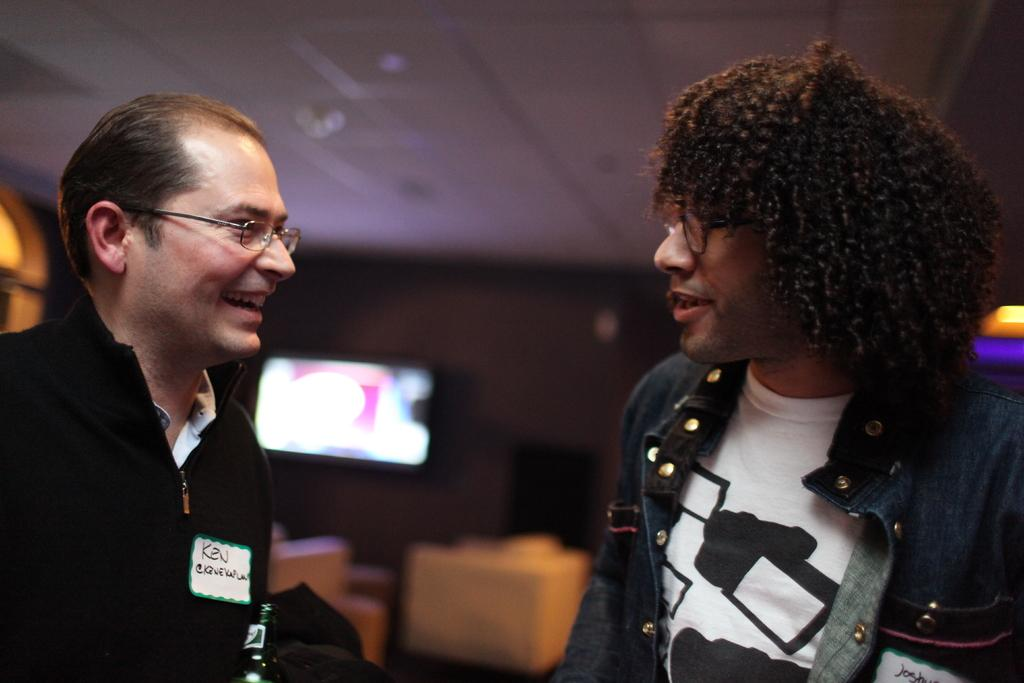How many people are in the image? There are two men standing in the image. What are the expressions on their faces? The men are smiling in the image. What can be seen in the background of the image? There are couches in the background of the image. What is on the ground in the image? There is a television on the ground in the image. How would you describe the background of the image? The background of the image is blurry. What type of juice is being served in the image? There is no juice present in the image. How many bushes can be seen in the image? There are no bushes visible in the image. 